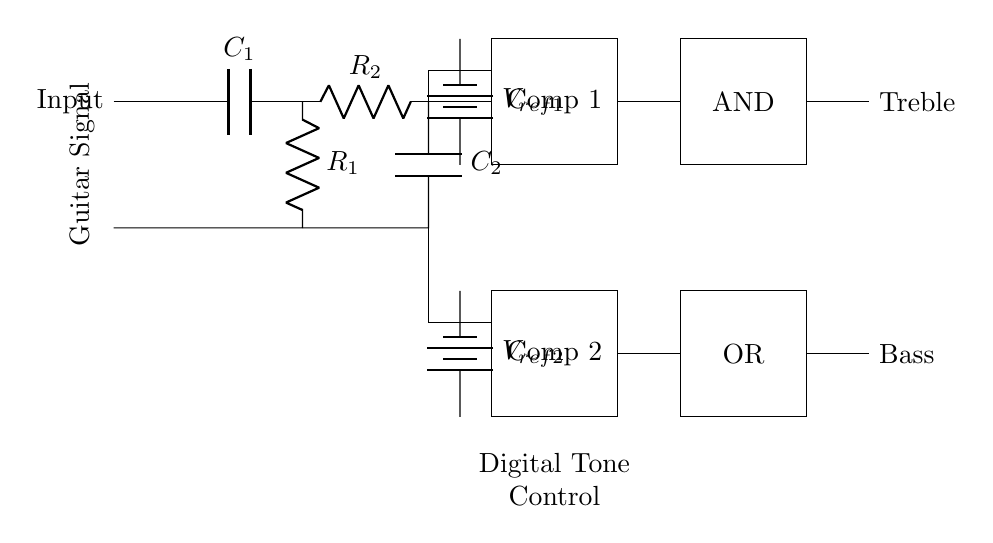What is the input signal? The input signal is the guitar signal, which is indicated by the label on the left side of the circuit diagram. It represents the audio signal from a guitar.
Answer: Guitar Signal What component acts as a high-pass filter? The high-pass filter is formed by the capacitor labeled C1 and the resistor labeled R1. The capacitor allows high-frequency signals to pass while blocking low-frequency signals.
Answer: C1 and R1 What is the function of the comparators? The comparators (labeled Comp 1 and Comp 2) are used to compare the input signal to the reference voltages, determining whether the output signals should be activated based on the comparison.
Answer: Compare input to reference voltages What logic gate is used for treble control? The logic gate used for treble control is the AND gate. The specific connections indicate it processes the outputs from the high-pass filter and the comparator to control the treble frequency.
Answer: AND How many batteries are present in the circuit? There are two batteries labeled as reference voltages, one for each comparator (V ref 1 and V ref 2). They provide the necessary voltage levels for the comparators to function effectively.
Answer: 2 Which components are involved in the bass control output? The bass control output involves the OR gate, which processes the output from the low-pass filter and the second comparator to control the bass frequencies.
Answer: OR gate and second comparator What does the diagram represent? The diagram represents a digital tone control circuit specifically designed for guitar amplifiers. This circuit utilizes logic gates to process the audio signal and adjust the treble and bass frequencies.
Answer: Digital Tone Control 